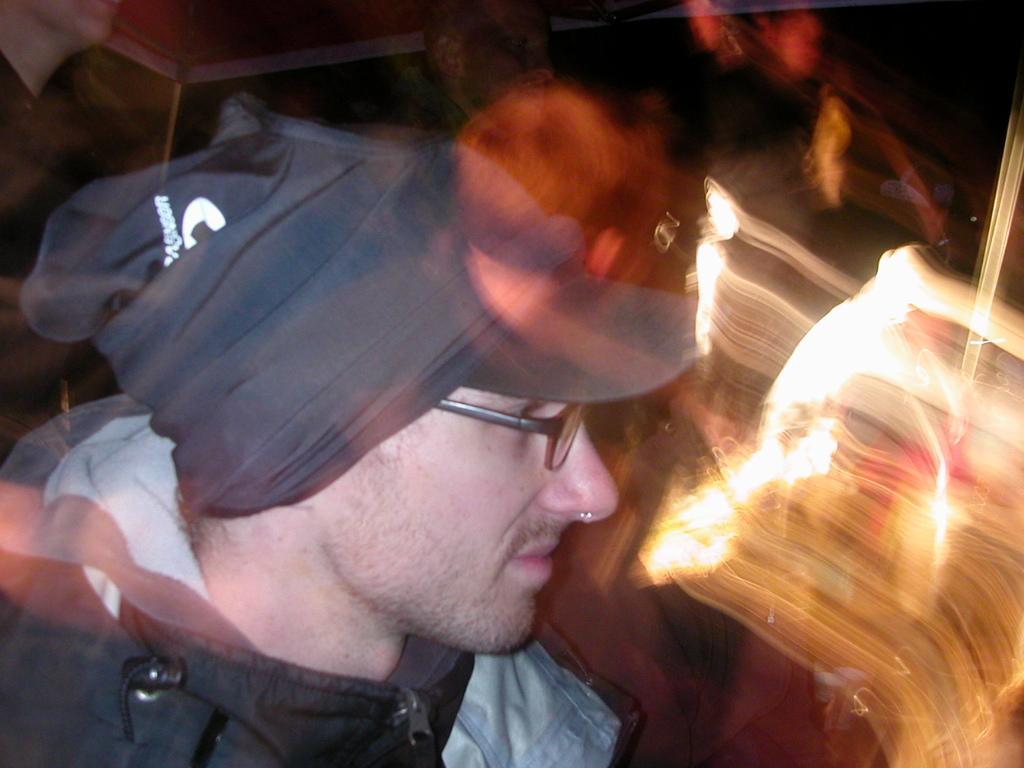In one or two sentences, can you explain what this image depicts? In the foreground of this picture there is a person wearing a hat and spectacles. The background of the image is blurry and we can see the lights and some other objects in the background. 